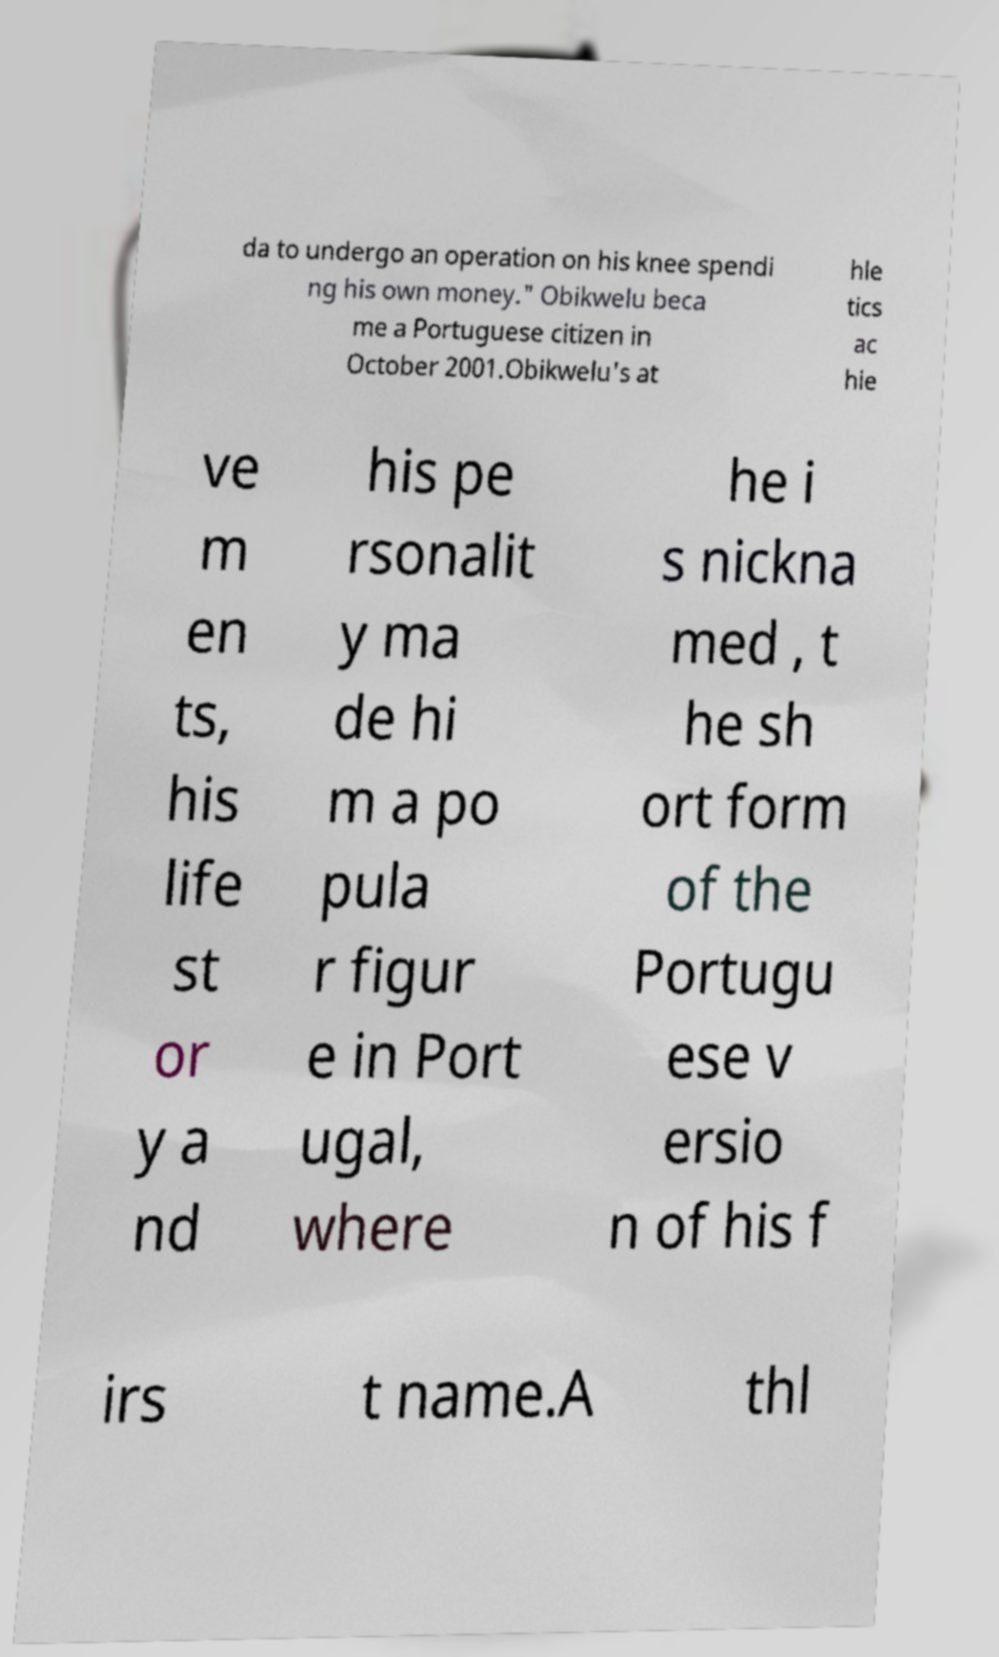Please identify and transcribe the text found in this image. da to undergo an operation on his knee spendi ng his own money." Obikwelu beca me a Portuguese citizen in October 2001.Obikwelu's at hle tics ac hie ve m en ts, his life st or y a nd his pe rsonalit y ma de hi m a po pula r figur e in Port ugal, where he i s nickna med , t he sh ort form of the Portugu ese v ersio n of his f irs t name.A thl 